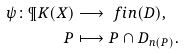<formula> <loc_0><loc_0><loc_500><loc_500>\psi \colon \P K ( X ) & \longrightarrow \ f i n ( D ) , \\ P & \longmapsto P \cap D _ { n ( P ) } .</formula> 